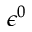Convert formula to latex. <formula><loc_0><loc_0><loc_500><loc_500>\epsilon ^ { 0 }</formula> 